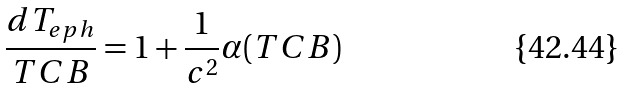<formula> <loc_0><loc_0><loc_500><loc_500>\frac { d T _ { e p h } } { T C B } = 1 + \frac { 1 } { c ^ { 2 } } \alpha ( T C B )</formula> 